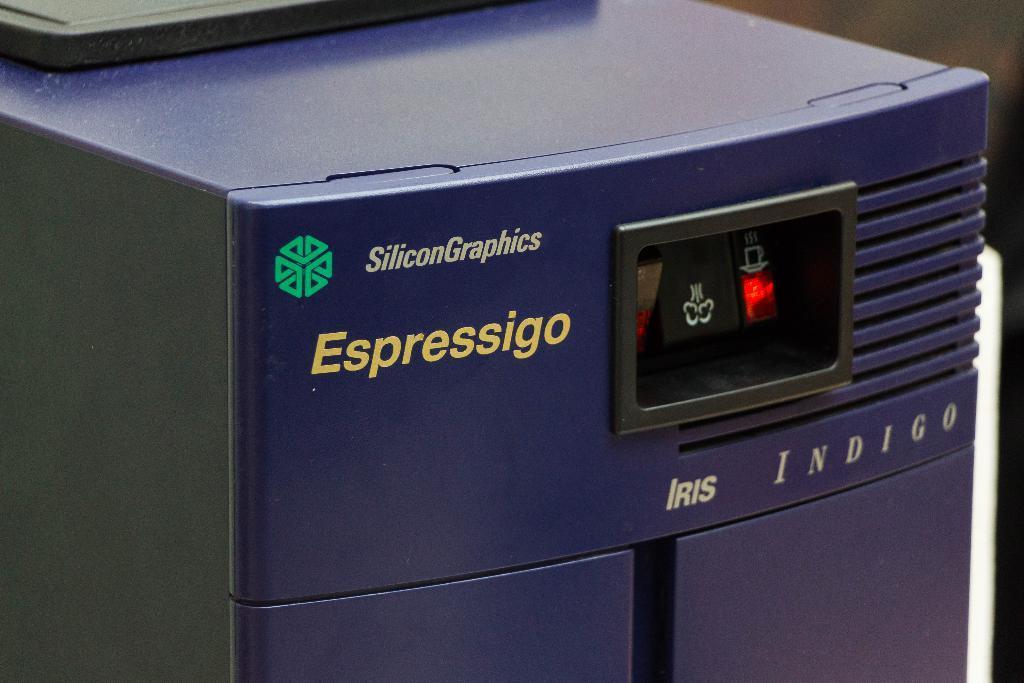In one or two sentences, can you explain what this image depicts? In this image there is a coffee machine in the middle. 